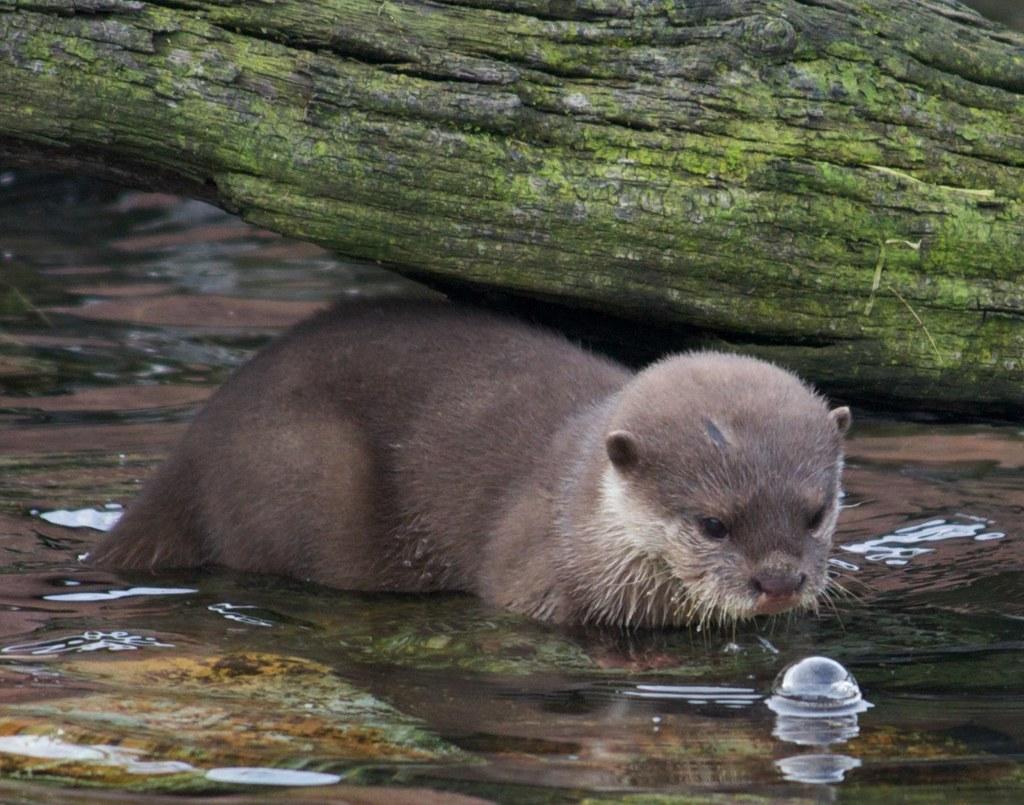In one or two sentences, can you explain what this image depicts? In this image there is an otter, there is water towards the bottom of the image, there is a water bubble, there is a tree trunk towards the top of the image. 